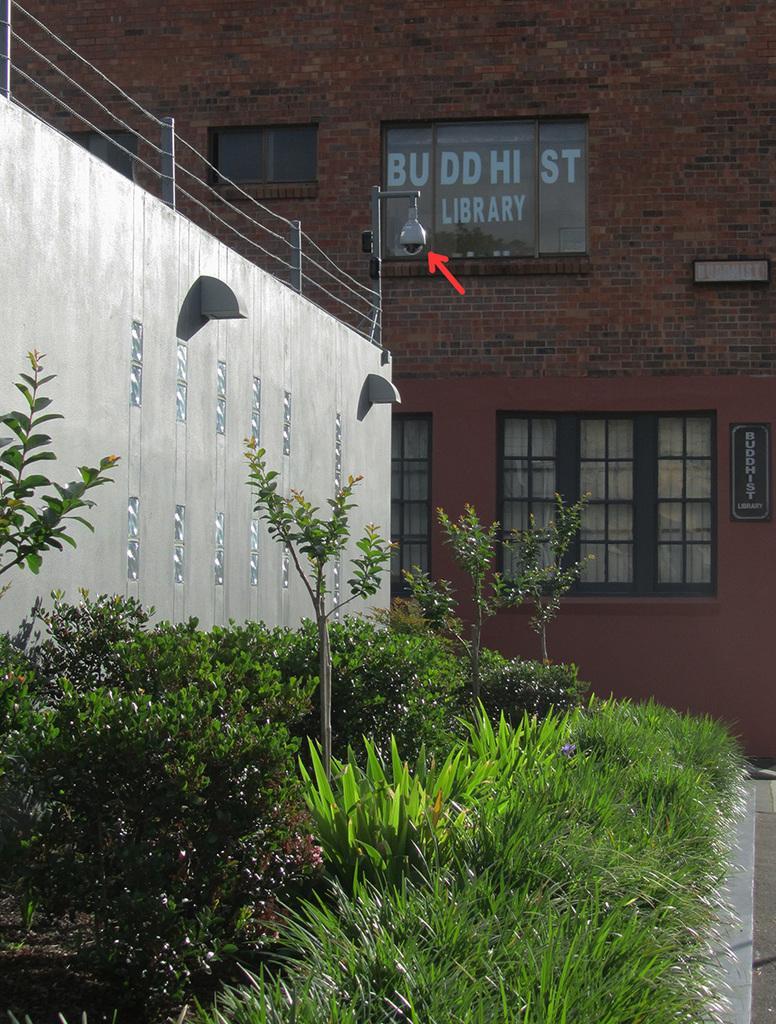Could you give a brief overview of what you see in this image? In this image, we can see a building and there are boards with text and we can see windows, railings, a light and there are plants. At the bottom, there is a road. 